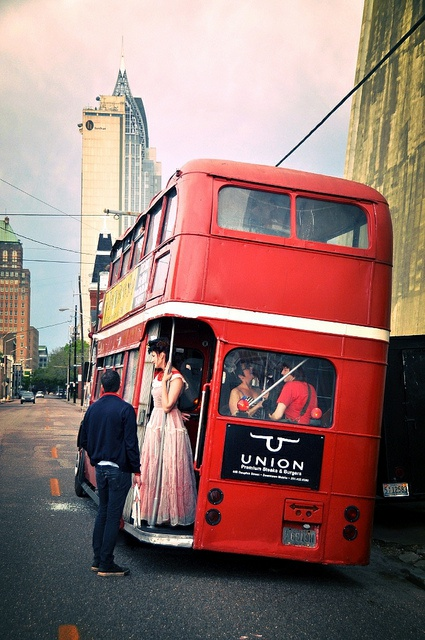Describe the objects in this image and their specific colors. I can see bus in darkgray, black, brown, red, and salmon tones, people in darkgray, lightgray, lightpink, brown, and gray tones, people in darkgray, black, navy, gray, and brown tones, people in darkgray, salmon, brown, and black tones, and people in darkgray, brown, gray, tan, and black tones in this image. 